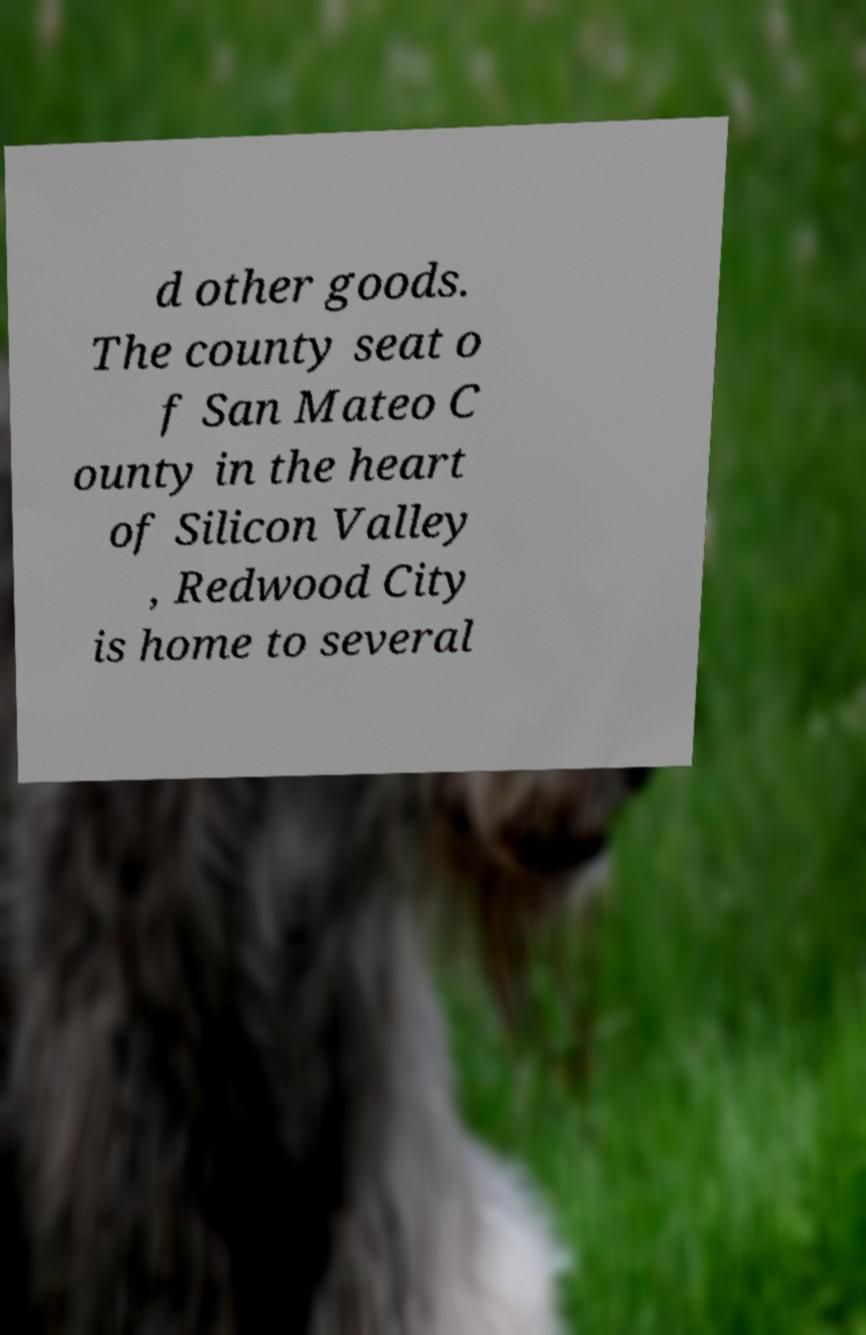Can you accurately transcribe the text from the provided image for me? d other goods. The county seat o f San Mateo C ounty in the heart of Silicon Valley , Redwood City is home to several 